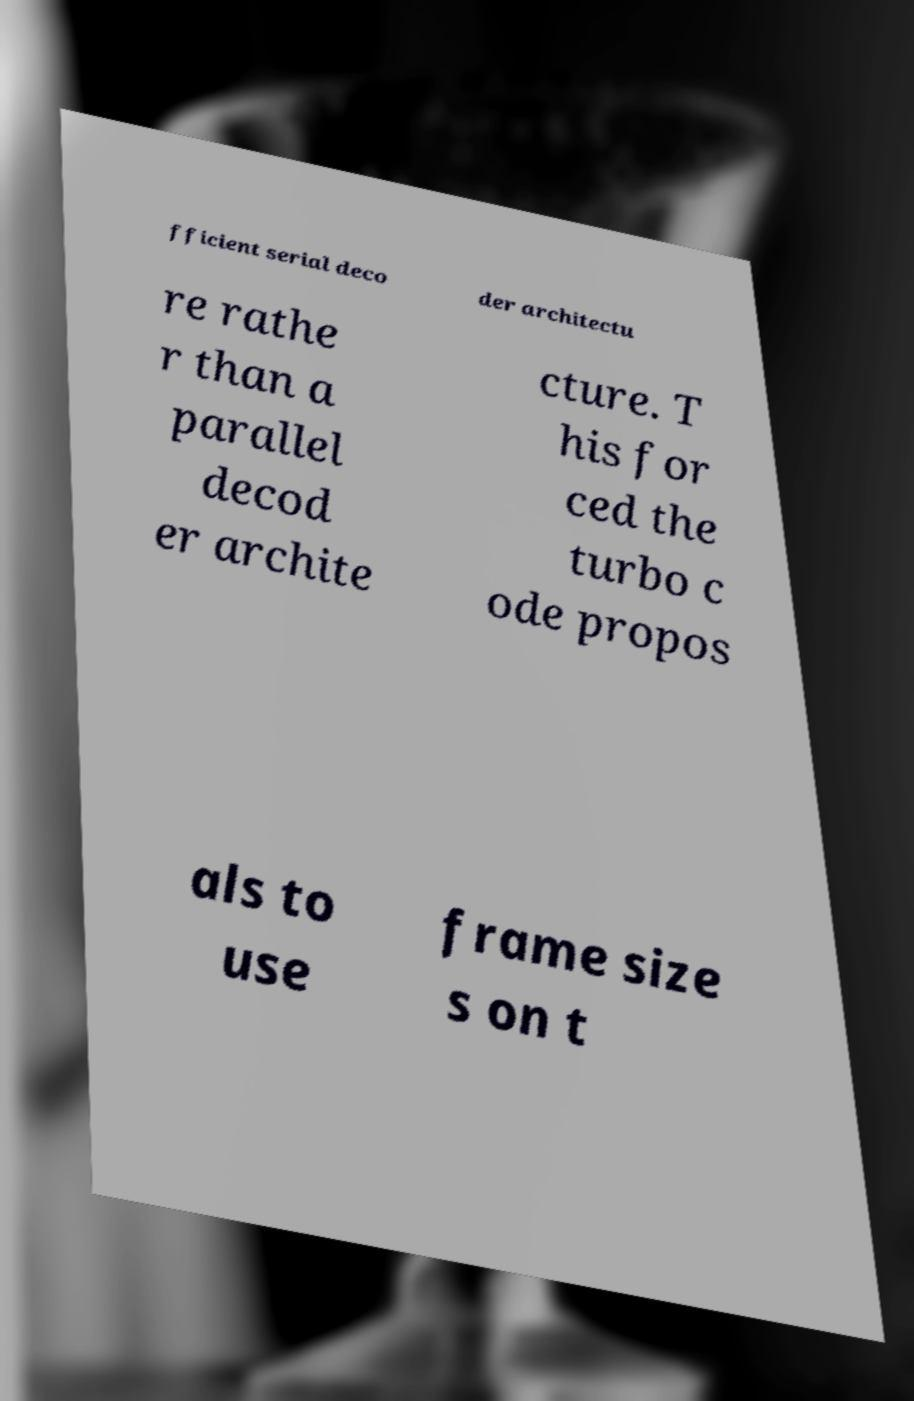Can you read and provide the text displayed in the image?This photo seems to have some interesting text. Can you extract and type it out for me? fficient serial deco der architectu re rathe r than a parallel decod er archite cture. T his for ced the turbo c ode propos als to use frame size s on t 